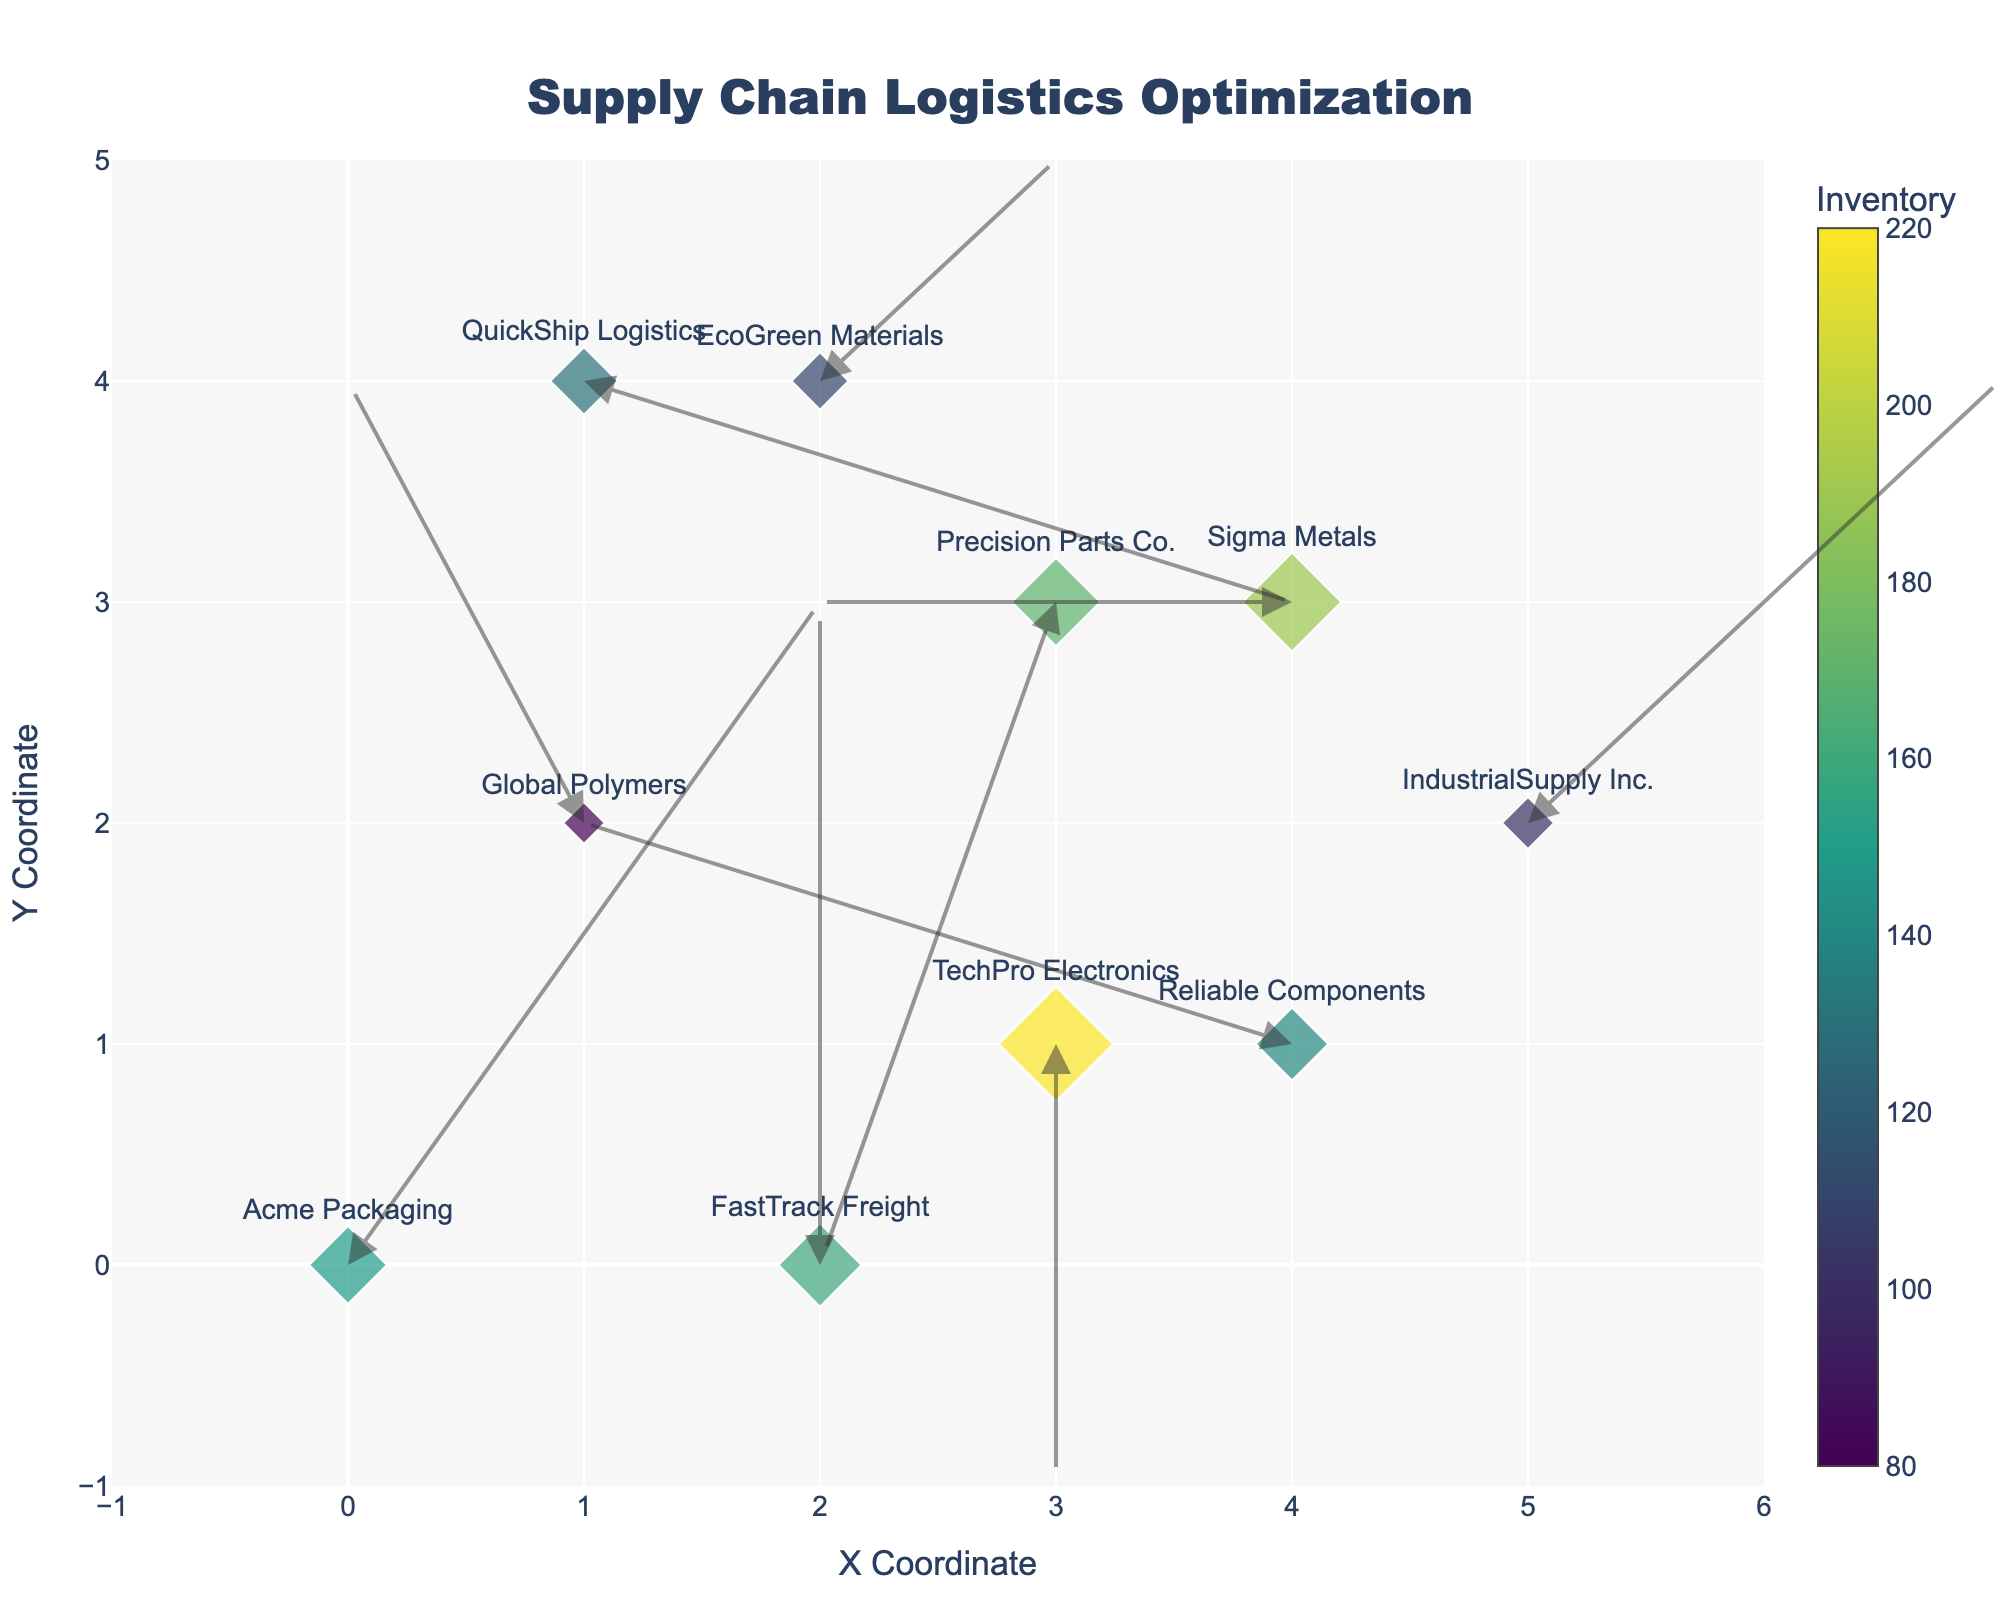What's the title of the figure? The title can be found at the top center of the figure in large font.
Answer: Supply Chain Logistics Optimization How many suppliers are depicted in the plot? Count each unique supplier name labeled near the markers. There are 10 suppliers listed.
Answer: 10 Which supplier has the highest inventory level and what is it? Look for the largest marker based on size, check the color scale for the highest value, and hover over the marker to confirm.
Answer: TechPro Electronics, 220 Which direction and from which coordinate does Reliable Components' inventory move? Find the marker labeled "Reliable Components" and follow the arrow originating from it.
Answer: Right with a slight upward tilt, from (4, 1) What is the average inventory level of all suppliers? Sum up all the inventory values (150 + 80 + 220 + 110 + 190 + 130 + 170 + 100 + 160 + 140) and divide by the number of suppliers (10).
Answer: 145 Which supplier’s inventory moves vertically downwards, and from what coordinates? Identify the arrows pointing directly downward and check the corresponding supplier's label.
Answer: TechPro Electronics, from (3, 1) Compare the inventory levels of Sigma Metals and IndustrialSupply Inc. Which one is higher? Locate both suppliers on the plot and compare the values next to the color scale.
Answer: Sigma Metals, 190 is higher What is the approximate average movement length of all suppliers' inventory? Calculate the Euclidean length for each vector (square root of (u^2 + v^2)) and then find the average of these lengths.
Answer: Approximately 2.09 How does the y-coordinate of FastTrack Freight compare to that of QuickShip Logistics? Check the y-coordinates of both suppliers and compare them numerically.
Answer: FastTrack Freight (0) is less than QuickShip Logistics (4) What is the combined inventory level of suppliers whose inventory moves horizontally? Identify suppliers where the 'v' component of movement is 0. Sum their inventories: Sigma Metals (190) + Reliable Components (140).
Answer: 330 